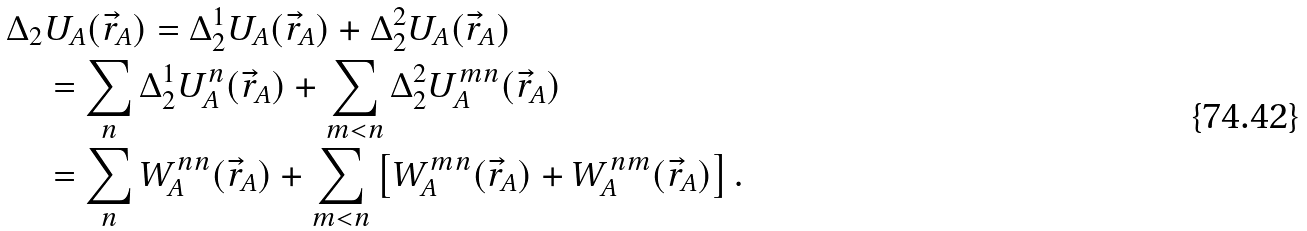Convert formula to latex. <formula><loc_0><loc_0><loc_500><loc_500>& \Delta _ { 2 } U _ { A } ( \vec { r } _ { A } ) = \Delta _ { 2 } ^ { 1 } U _ { A } ( \vec { r } _ { A } ) + \Delta _ { 2 } ^ { 2 } U _ { A } ( \vec { r } _ { A } ) \\ & \quad = \sum _ { n } \Delta _ { 2 } ^ { 1 } U _ { A } ^ { n } ( \vec { r } _ { A } ) + \sum _ { m < n } \Delta _ { 2 } ^ { 2 } U _ { A } ^ { m n } ( \vec { r } _ { A } ) \\ & \quad = \sum _ { n } W _ { A } ^ { n n } ( \vec { r } _ { A } ) + \sum _ { m < n } \left [ W _ { A } ^ { m n } ( \vec { r } _ { A } ) + W _ { A } ^ { n m } ( \vec { r } _ { A } ) \right ] .</formula> 